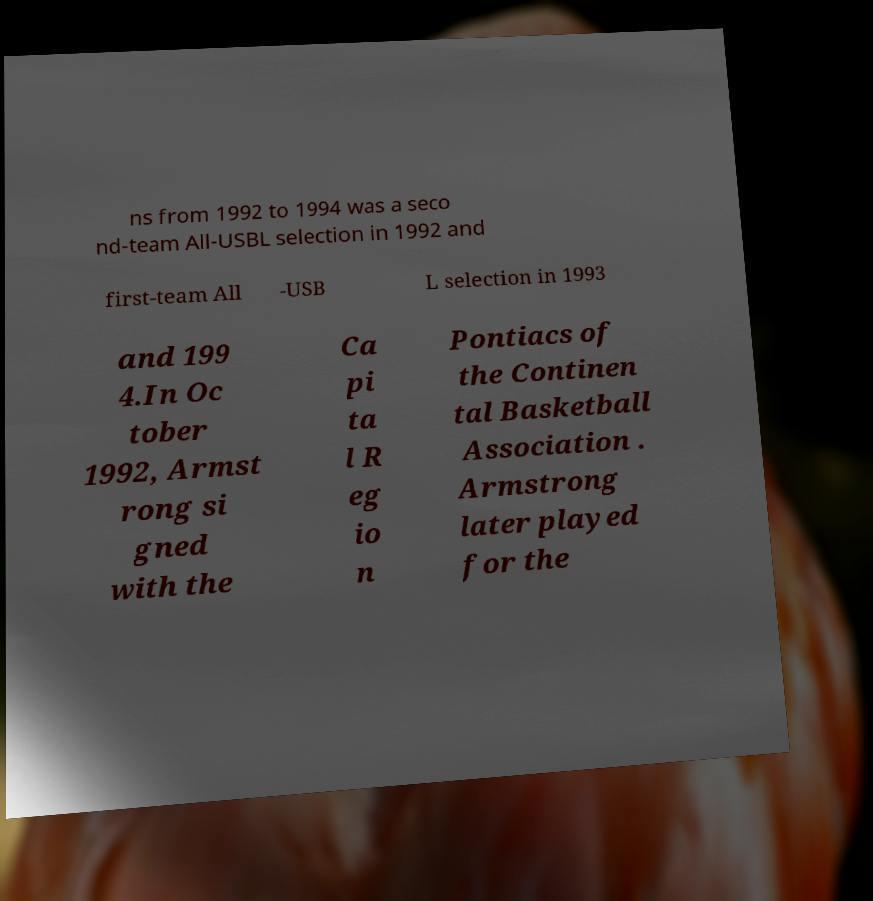Please identify and transcribe the text found in this image. ns from 1992 to 1994 was a seco nd-team All-USBL selection in 1992 and first-team All -USB L selection in 1993 and 199 4.In Oc tober 1992, Armst rong si gned with the Ca pi ta l R eg io n Pontiacs of the Continen tal Basketball Association . Armstrong later played for the 